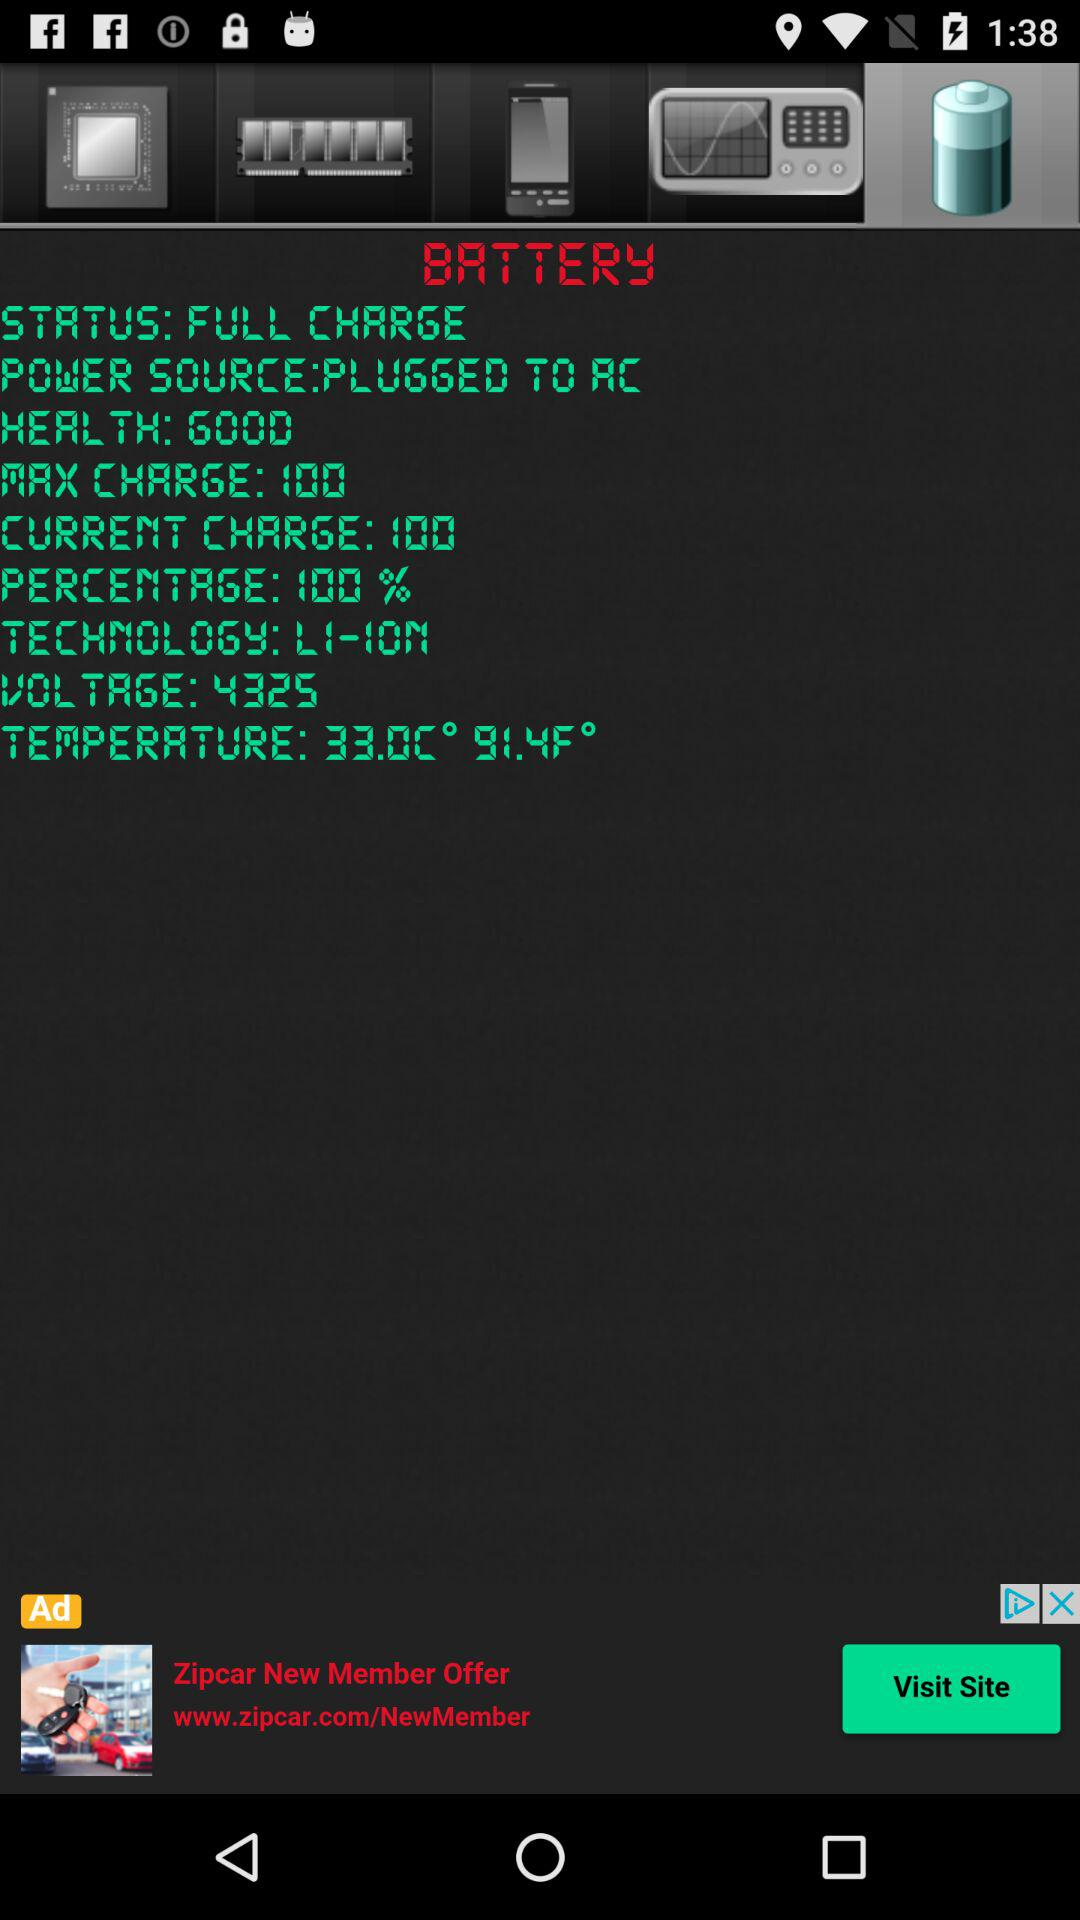How much is the current battery charge? The current battery charge is 100. 